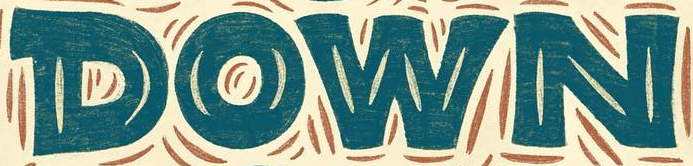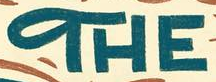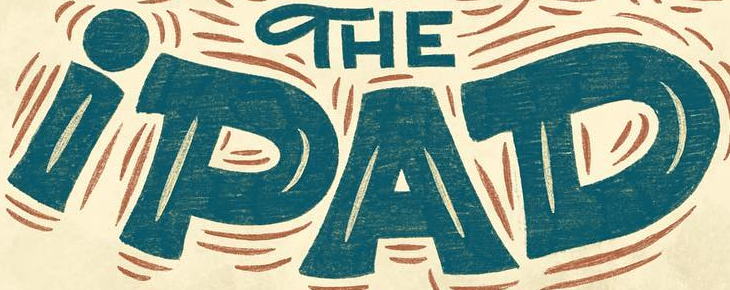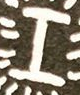What words are shown in these images in order, separated by a semicolon? DOWN; THE; iPAD; I 